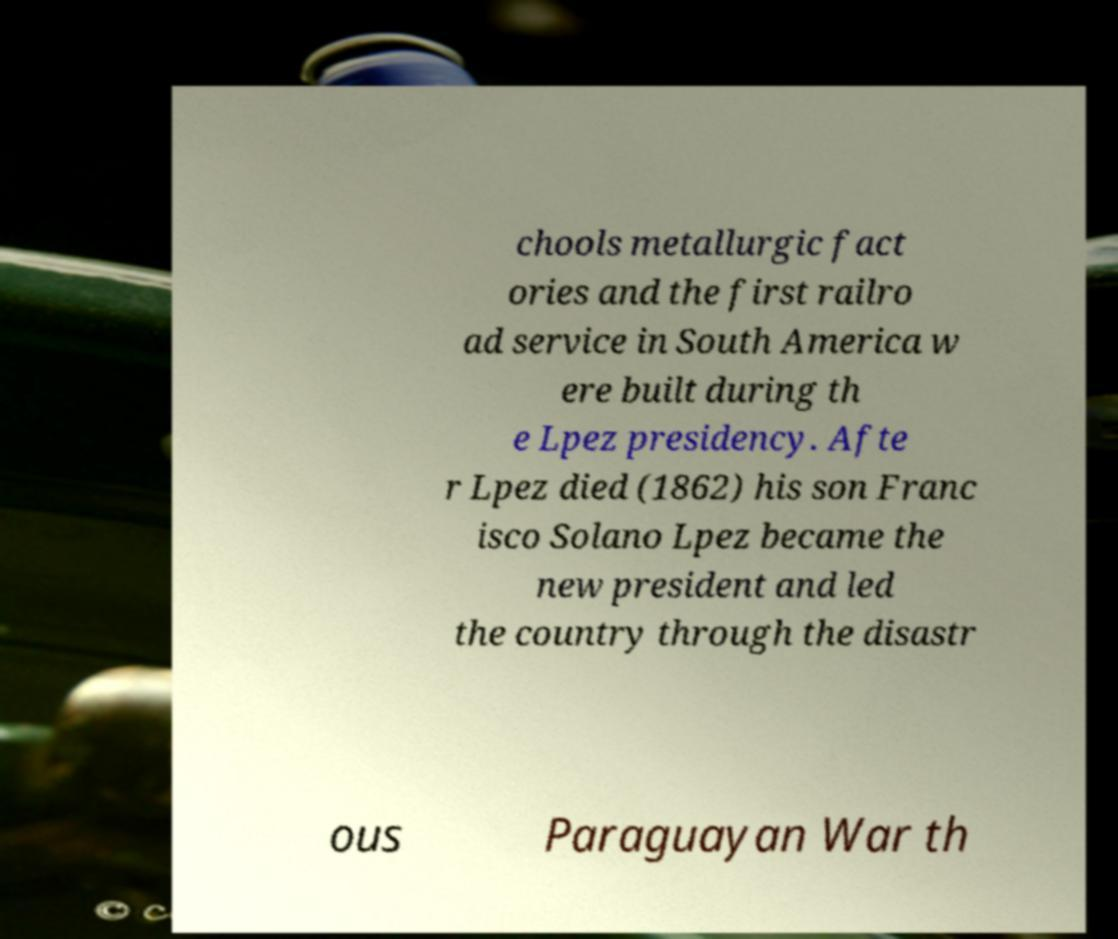Could you extract and type out the text from this image? chools metallurgic fact ories and the first railro ad service in South America w ere built during th e Lpez presidency. Afte r Lpez died (1862) his son Franc isco Solano Lpez became the new president and led the country through the disastr ous Paraguayan War th 